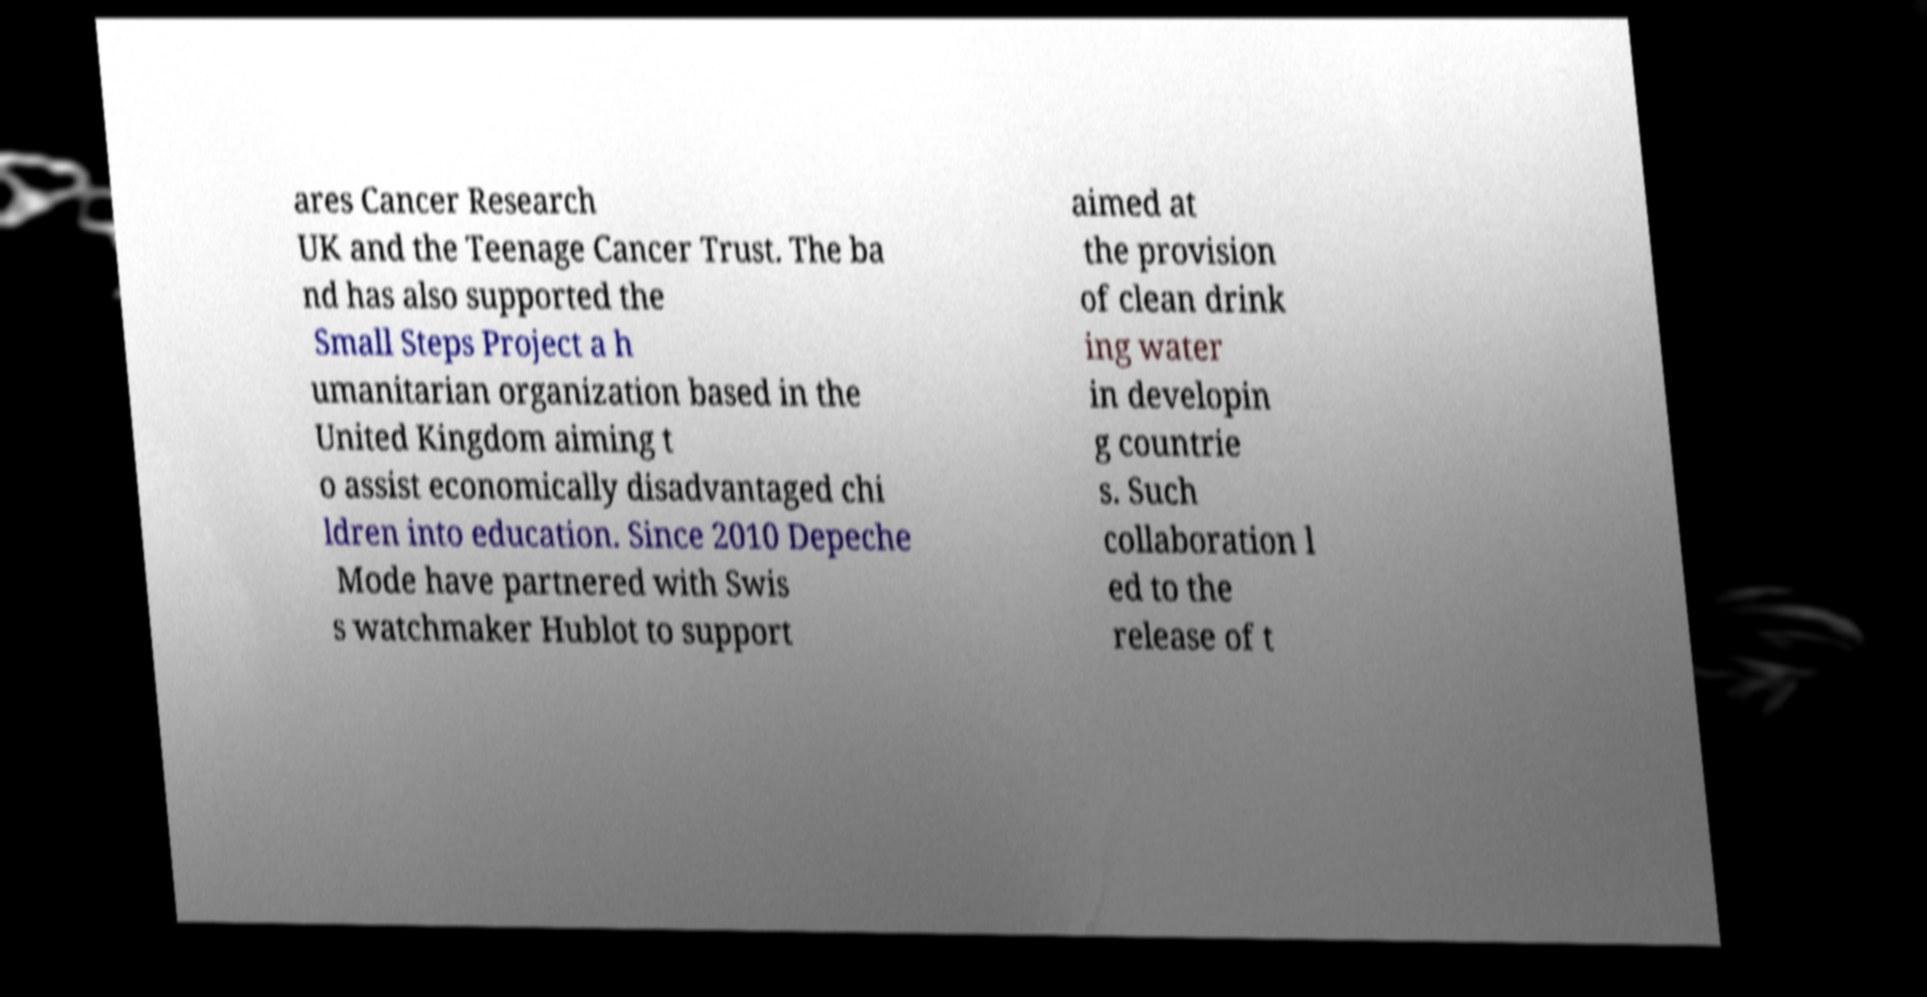Can you read and provide the text displayed in the image?This photo seems to have some interesting text. Can you extract and type it out for me? ares Cancer Research UK and the Teenage Cancer Trust. The ba nd has also supported the Small Steps Project a h umanitarian organization based in the United Kingdom aiming t o assist economically disadvantaged chi ldren into education. Since 2010 Depeche Mode have partnered with Swis s watchmaker Hublot to support aimed at the provision of clean drink ing water in developin g countrie s. Such collaboration l ed to the release of t 